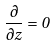Convert formula to latex. <formula><loc_0><loc_0><loc_500><loc_500>\frac { \partial } { \partial z } = 0</formula> 